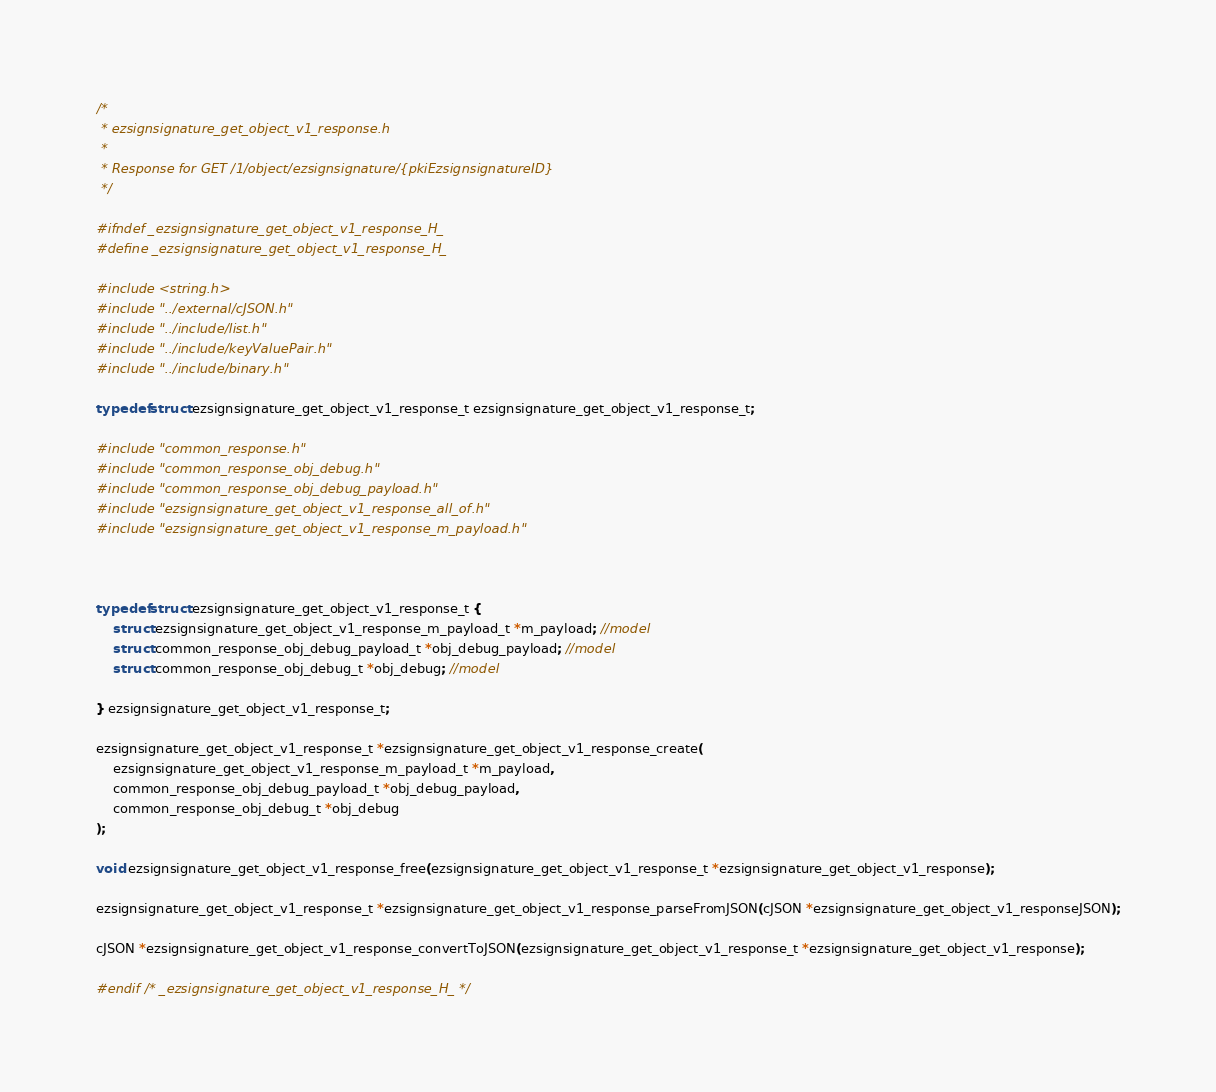<code> <loc_0><loc_0><loc_500><loc_500><_C_>/*
 * ezsignsignature_get_object_v1_response.h
 *
 * Response for GET /1/object/ezsignsignature/{pkiEzsignsignatureID}
 */

#ifndef _ezsignsignature_get_object_v1_response_H_
#define _ezsignsignature_get_object_v1_response_H_

#include <string.h>
#include "../external/cJSON.h"
#include "../include/list.h"
#include "../include/keyValuePair.h"
#include "../include/binary.h"

typedef struct ezsignsignature_get_object_v1_response_t ezsignsignature_get_object_v1_response_t;

#include "common_response.h"
#include "common_response_obj_debug.h"
#include "common_response_obj_debug_payload.h"
#include "ezsignsignature_get_object_v1_response_all_of.h"
#include "ezsignsignature_get_object_v1_response_m_payload.h"



typedef struct ezsignsignature_get_object_v1_response_t {
    struct ezsignsignature_get_object_v1_response_m_payload_t *m_payload; //model
    struct common_response_obj_debug_payload_t *obj_debug_payload; //model
    struct common_response_obj_debug_t *obj_debug; //model

} ezsignsignature_get_object_v1_response_t;

ezsignsignature_get_object_v1_response_t *ezsignsignature_get_object_v1_response_create(
    ezsignsignature_get_object_v1_response_m_payload_t *m_payload,
    common_response_obj_debug_payload_t *obj_debug_payload,
    common_response_obj_debug_t *obj_debug
);

void ezsignsignature_get_object_v1_response_free(ezsignsignature_get_object_v1_response_t *ezsignsignature_get_object_v1_response);

ezsignsignature_get_object_v1_response_t *ezsignsignature_get_object_v1_response_parseFromJSON(cJSON *ezsignsignature_get_object_v1_responseJSON);

cJSON *ezsignsignature_get_object_v1_response_convertToJSON(ezsignsignature_get_object_v1_response_t *ezsignsignature_get_object_v1_response);

#endif /* _ezsignsignature_get_object_v1_response_H_ */

</code> 